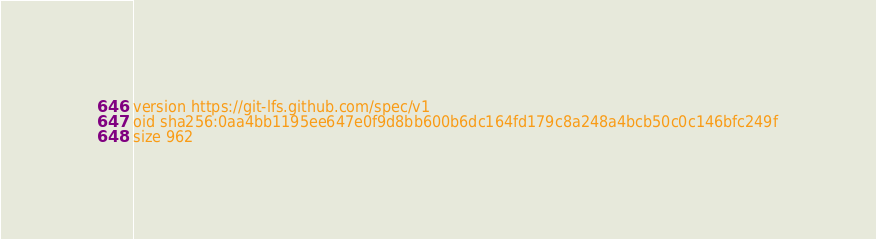Convert code to text. <code><loc_0><loc_0><loc_500><loc_500><_YAML_>version https://git-lfs.github.com/spec/v1
oid sha256:0aa4bb1195ee647e0f9d8bb600b6dc164fd179c8a248a4bcb50c0c146bfc249f
size 962
</code> 